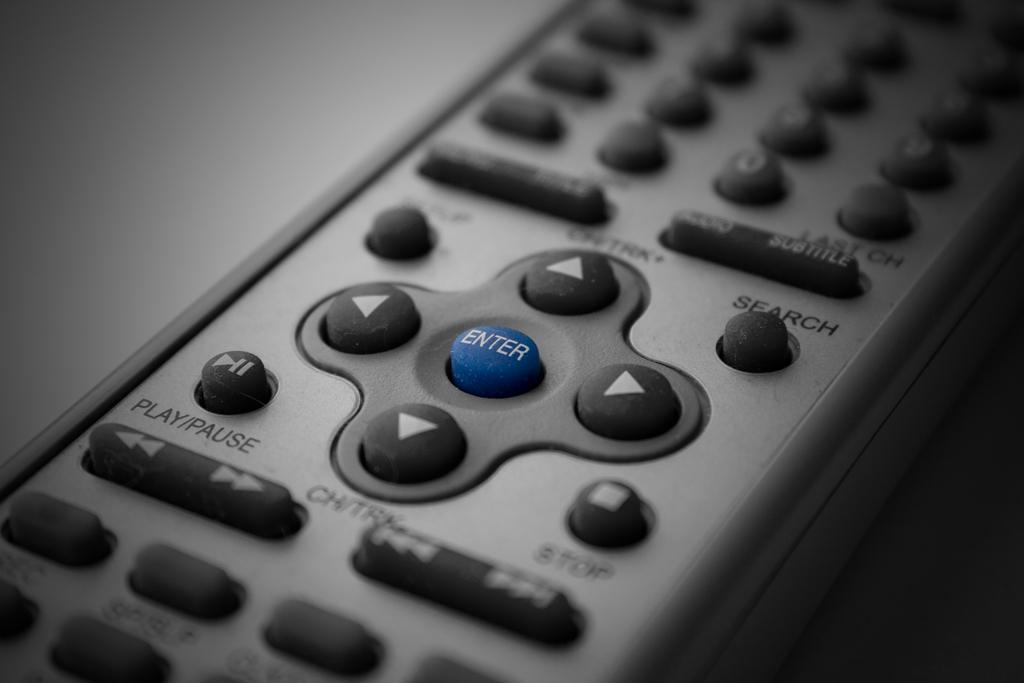Provide a one-sentence caption for the provided image. A remote device close up, focusing on the blue enter button. 